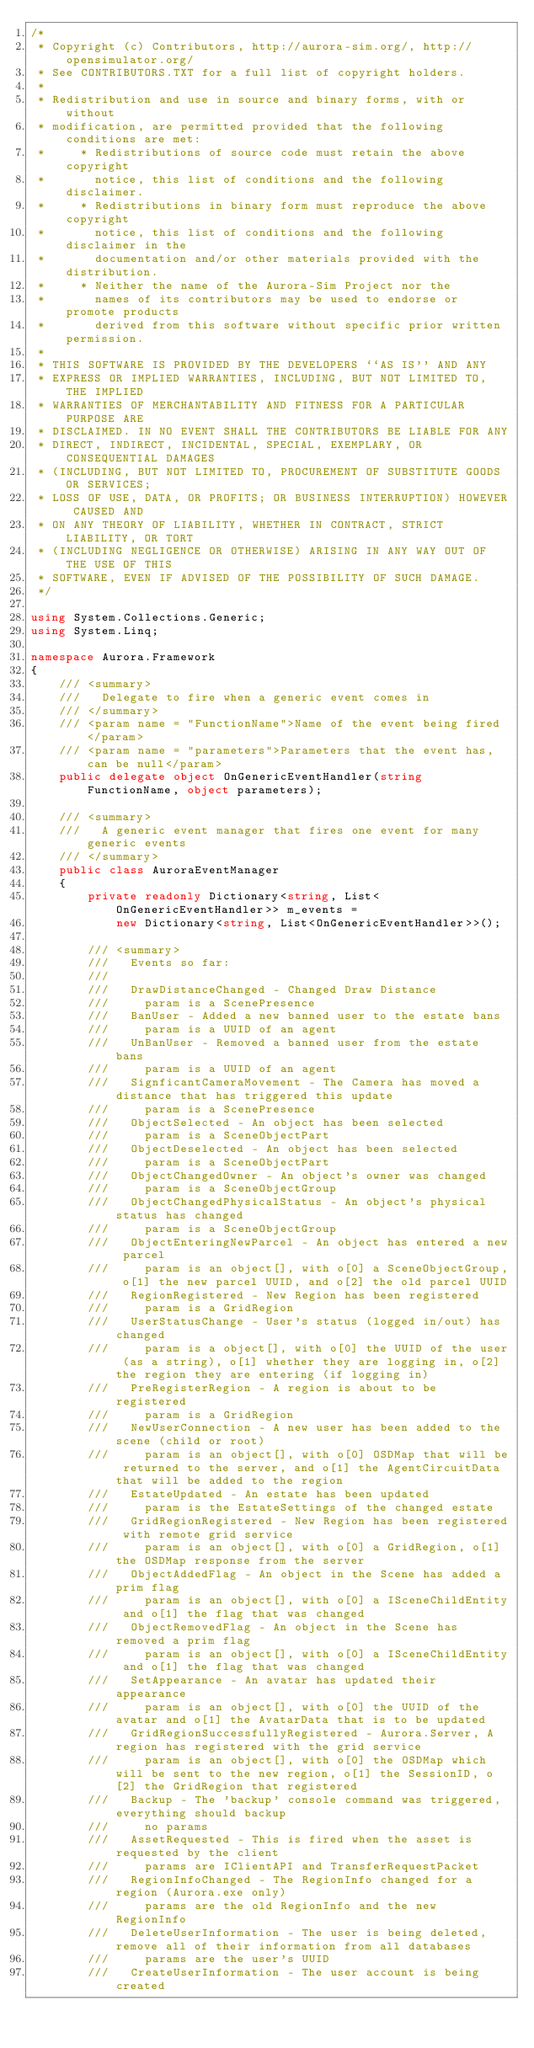<code> <loc_0><loc_0><loc_500><loc_500><_C#_>/*
 * Copyright (c) Contributors, http://aurora-sim.org/, http://opensimulator.org/
 * See CONTRIBUTORS.TXT for a full list of copyright holders.
 *
 * Redistribution and use in source and binary forms, with or without
 * modification, are permitted provided that the following conditions are met:
 *     * Redistributions of source code must retain the above copyright
 *       notice, this list of conditions and the following disclaimer.
 *     * Redistributions in binary form must reproduce the above copyright
 *       notice, this list of conditions and the following disclaimer in the
 *       documentation and/or other materials provided with the distribution.
 *     * Neither the name of the Aurora-Sim Project nor the
 *       names of its contributors may be used to endorse or promote products
 *       derived from this software without specific prior written permission.
 *
 * THIS SOFTWARE IS PROVIDED BY THE DEVELOPERS ``AS IS'' AND ANY
 * EXPRESS OR IMPLIED WARRANTIES, INCLUDING, BUT NOT LIMITED TO, THE IMPLIED
 * WARRANTIES OF MERCHANTABILITY AND FITNESS FOR A PARTICULAR PURPOSE ARE
 * DISCLAIMED. IN NO EVENT SHALL THE CONTRIBUTORS BE LIABLE FOR ANY
 * DIRECT, INDIRECT, INCIDENTAL, SPECIAL, EXEMPLARY, OR CONSEQUENTIAL DAMAGES
 * (INCLUDING, BUT NOT LIMITED TO, PROCUREMENT OF SUBSTITUTE GOODS OR SERVICES;
 * LOSS OF USE, DATA, OR PROFITS; OR BUSINESS INTERRUPTION) HOWEVER CAUSED AND
 * ON ANY THEORY OF LIABILITY, WHETHER IN CONTRACT, STRICT LIABILITY, OR TORT
 * (INCLUDING NEGLIGENCE OR OTHERWISE) ARISING IN ANY WAY OUT OF THE USE OF THIS
 * SOFTWARE, EVEN IF ADVISED OF THE POSSIBILITY OF SUCH DAMAGE.
 */

using System.Collections.Generic;
using System.Linq;

namespace Aurora.Framework
{
    /// <summary>
    ///   Delegate to fire when a generic event comes in
    /// </summary>
    /// <param name = "FunctionName">Name of the event being fired</param>
    /// <param name = "parameters">Parameters that the event has, can be null</param>
    public delegate object OnGenericEventHandler(string FunctionName, object parameters);

    /// <summary>
    ///   A generic event manager that fires one event for many generic events
    /// </summary>
    public class AuroraEventManager
    {
        private readonly Dictionary<string, List<OnGenericEventHandler>> m_events =
            new Dictionary<string, List<OnGenericEventHandler>>();

        /// <summary>
        ///   Events so far:
        /// 
        ///   DrawDistanceChanged - Changed Draw Distance
        ///     param is a ScenePresence
        ///   BanUser - Added a new banned user to the estate bans
        ///     param is a UUID of an agent
        ///   UnBanUser - Removed a banned user from the estate bans
        ///     param is a UUID of an agent
        ///   SignficantCameraMovement - The Camera has moved a distance that has triggered this update
        ///     param is a ScenePresence
        ///   ObjectSelected - An object has been selected
        ///     param is a SceneObjectPart
        ///   ObjectDeselected - An object has been selected
        ///     param is a SceneObjectPart
        ///   ObjectChangedOwner - An object's owner was changed
        ///     param is a SceneObjectGroup
        ///   ObjectChangedPhysicalStatus - An object's physical status has changed
        ///     param is a SceneObjectGroup
        ///   ObjectEnteringNewParcel - An object has entered a new parcel
        ///     param is an object[], with o[0] a SceneObjectGroup, o[1] the new parcel UUID, and o[2] the old parcel UUID
        ///   RegionRegistered - New Region has been registered
        ///     param is a GridRegion
        ///   UserStatusChange - User's status (logged in/out) has changed
        ///     param is a object[], with o[0] the UUID of the user (as a string), o[1] whether they are logging in, o[2] the region they are entering (if logging in)
        ///   PreRegisterRegion - A region is about to be registered
        ///     param is a GridRegion
        ///   NewUserConnection - A new user has been added to the scene (child or root)
        ///     param is an object[], with o[0] OSDMap that will be returned to the server, and o[1] the AgentCircuitData that will be added to the region
        ///   EstateUpdated - An estate has been updated
        ///     param is the EstateSettings of the changed estate
        ///   GridRegionRegistered - New Region has been registered with remote grid service
        ///     param is an object[], with o[0] a GridRegion, o[1] the OSDMap response from the server
        ///   ObjectAddedFlag - An object in the Scene has added a prim flag
        ///     param is an object[], with o[0] a ISceneChildEntity and o[1] the flag that was changed
        ///   ObjectRemovedFlag - An object in the Scene has removed a prim flag
        ///     param is an object[], with o[0] a ISceneChildEntity and o[1] the flag that was changed
        ///   SetAppearance - An avatar has updated their appearance
        ///     param is an object[], with o[0] the UUID of the avatar and o[1] the AvatarData that is to be updated
        ///   GridRegionSuccessfullyRegistered - Aurora.Server, A region has registered with the grid service
        ///     param is an object[], with o[0] the OSDMap which will be sent to the new region, o[1] the SessionID, o[2] the GridRegion that registered
        ///   Backup - The 'backup' console command was triggered, everything should backup
        ///     no params
        ///   AssetRequested - This is fired when the asset is requested by the client
        ///     params are IClientAPI and TransferRequestPacket
        ///   RegionInfoChanged - The RegionInfo changed for a region (Aurora.exe only)
        ///     params are the old RegionInfo and the new RegionInfo
        ///   DeleteUserInformation - The user is being deleted, remove all of their information from all databases
        ///     params are the user's UUID
        ///   CreateUserInformation - The user account is being created</code> 